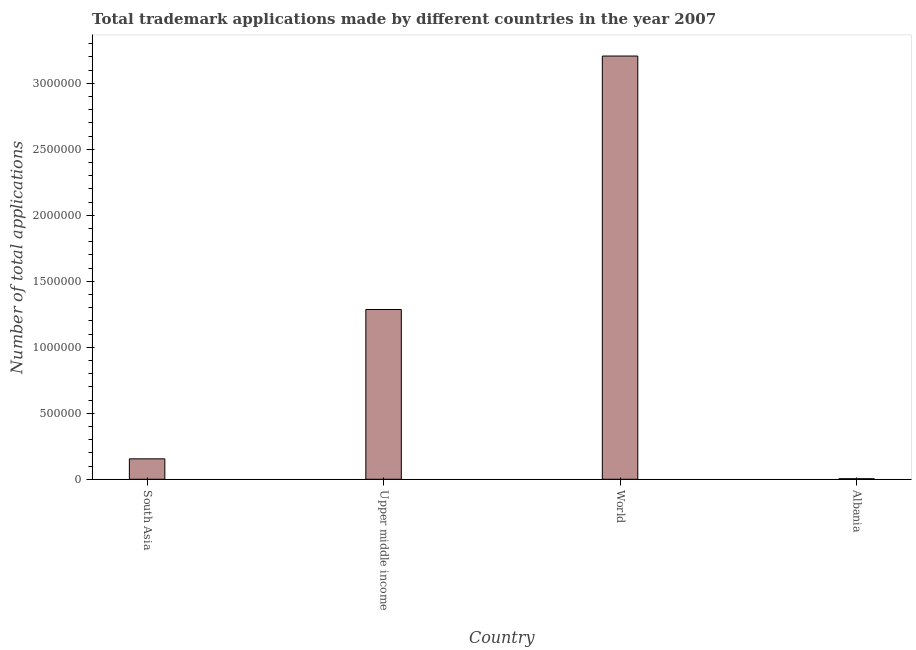Does the graph contain any zero values?
Ensure brevity in your answer.  No. Does the graph contain grids?
Provide a short and direct response. No. What is the title of the graph?
Provide a short and direct response. Total trademark applications made by different countries in the year 2007. What is the label or title of the X-axis?
Make the answer very short. Country. What is the label or title of the Y-axis?
Make the answer very short. Number of total applications. What is the number of trademark applications in Upper middle income?
Provide a short and direct response. 1.29e+06. Across all countries, what is the maximum number of trademark applications?
Offer a very short reply. 3.21e+06. Across all countries, what is the minimum number of trademark applications?
Keep it short and to the point. 4163. In which country was the number of trademark applications maximum?
Give a very brief answer. World. In which country was the number of trademark applications minimum?
Offer a terse response. Albania. What is the sum of the number of trademark applications?
Provide a succinct answer. 4.65e+06. What is the difference between the number of trademark applications in Albania and Upper middle income?
Your answer should be compact. -1.28e+06. What is the average number of trademark applications per country?
Your answer should be very brief. 1.16e+06. What is the median number of trademark applications?
Provide a succinct answer. 7.21e+05. In how many countries, is the number of trademark applications greater than 1400000 ?
Provide a succinct answer. 1. What is the ratio of the number of trademark applications in Albania to that in South Asia?
Offer a terse response. 0.03. Is the difference between the number of trademark applications in Albania and South Asia greater than the difference between any two countries?
Your answer should be compact. No. What is the difference between the highest and the second highest number of trademark applications?
Ensure brevity in your answer.  1.92e+06. What is the difference between the highest and the lowest number of trademark applications?
Provide a succinct answer. 3.20e+06. How many bars are there?
Keep it short and to the point. 4. How many countries are there in the graph?
Your response must be concise. 4. What is the difference between two consecutive major ticks on the Y-axis?
Your response must be concise. 5.00e+05. What is the Number of total applications of South Asia?
Offer a very short reply. 1.55e+05. What is the Number of total applications in Upper middle income?
Make the answer very short. 1.29e+06. What is the Number of total applications of World?
Keep it short and to the point. 3.21e+06. What is the Number of total applications of Albania?
Your response must be concise. 4163. What is the difference between the Number of total applications in South Asia and Upper middle income?
Make the answer very short. -1.13e+06. What is the difference between the Number of total applications in South Asia and World?
Provide a succinct answer. -3.05e+06. What is the difference between the Number of total applications in South Asia and Albania?
Your answer should be very brief. 1.51e+05. What is the difference between the Number of total applications in Upper middle income and World?
Your response must be concise. -1.92e+06. What is the difference between the Number of total applications in Upper middle income and Albania?
Keep it short and to the point. 1.28e+06. What is the difference between the Number of total applications in World and Albania?
Offer a very short reply. 3.20e+06. What is the ratio of the Number of total applications in South Asia to that in Upper middle income?
Your answer should be very brief. 0.12. What is the ratio of the Number of total applications in South Asia to that in World?
Offer a terse response. 0.05. What is the ratio of the Number of total applications in South Asia to that in Albania?
Provide a short and direct response. 37.21. What is the ratio of the Number of total applications in Upper middle income to that in World?
Provide a short and direct response. 0.4. What is the ratio of the Number of total applications in Upper middle income to that in Albania?
Offer a very short reply. 309.01. What is the ratio of the Number of total applications in World to that in Albania?
Offer a very short reply. 770.34. 